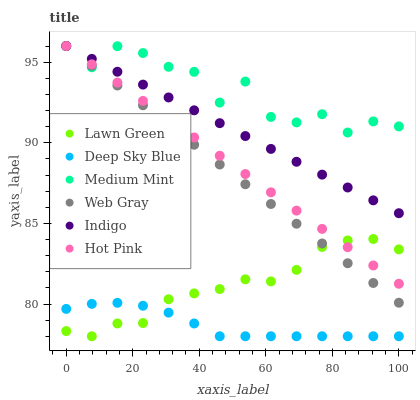Does Deep Sky Blue have the minimum area under the curve?
Answer yes or no. Yes. Does Medium Mint have the maximum area under the curve?
Answer yes or no. Yes. Does Lawn Green have the minimum area under the curve?
Answer yes or no. No. Does Lawn Green have the maximum area under the curve?
Answer yes or no. No. Is Indigo the smoothest?
Answer yes or no. Yes. Is Medium Mint the roughest?
Answer yes or no. Yes. Is Lawn Green the smoothest?
Answer yes or no. No. Is Lawn Green the roughest?
Answer yes or no. No. Does Lawn Green have the lowest value?
Answer yes or no. Yes. Does Web Gray have the lowest value?
Answer yes or no. No. Does Hot Pink have the highest value?
Answer yes or no. Yes. Does Lawn Green have the highest value?
Answer yes or no. No. Is Deep Sky Blue less than Web Gray?
Answer yes or no. Yes. Is Hot Pink greater than Deep Sky Blue?
Answer yes or no. Yes. Does Hot Pink intersect Web Gray?
Answer yes or no. Yes. Is Hot Pink less than Web Gray?
Answer yes or no. No. Is Hot Pink greater than Web Gray?
Answer yes or no. No. Does Deep Sky Blue intersect Web Gray?
Answer yes or no. No. 